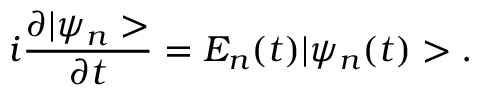Convert formula to latex. <formula><loc_0><loc_0><loc_500><loc_500>i \frac { \partial | \psi _ { n } > } { \partial t } = E _ { n } ( t ) | \psi _ { n } ( t ) > .</formula> 